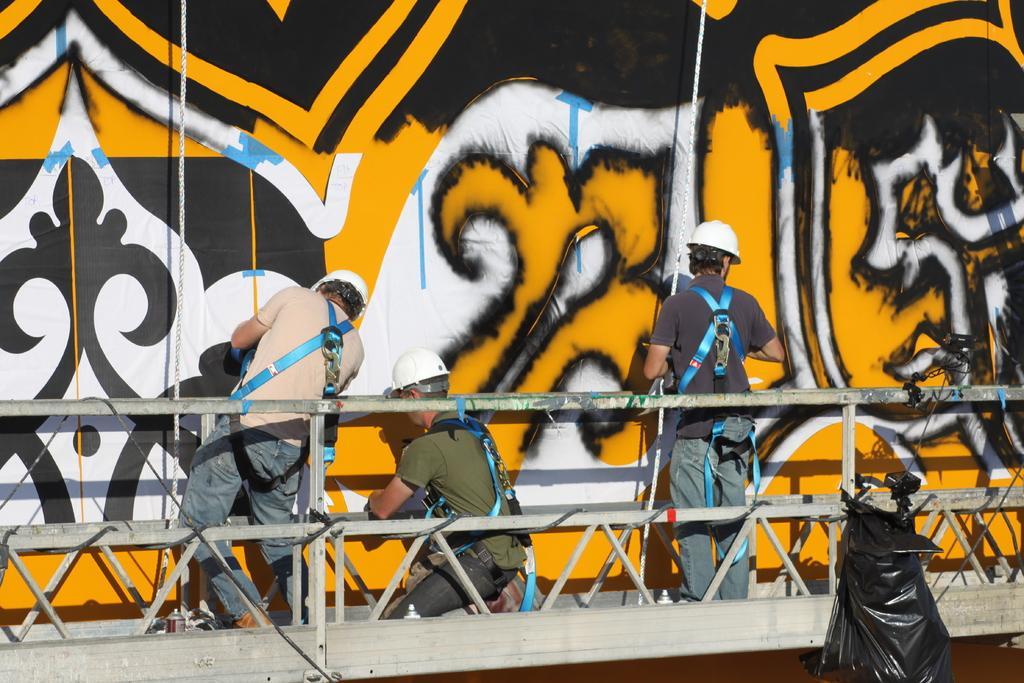In one or two sentences, can you explain what this image depicts? In this image I can see few people are wearing t-shirts, jeans, helmets on the heads and performing Graffiti on the wall. Beside these people there is a railing. On the right side a black color bag is attached to the railing. 